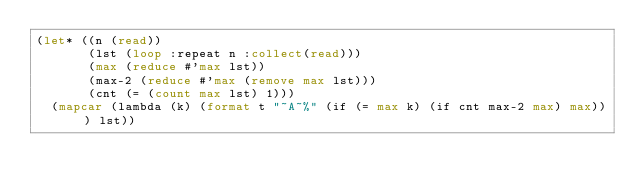Convert code to text. <code><loc_0><loc_0><loc_500><loc_500><_Lisp_>(let* ((n (read))
       (lst (loop :repeat n :collect(read)))
       (max (reduce #'max lst))
       (max-2 (reduce #'max (remove max lst)))
       (cnt (= (count max lst) 1)))
  (mapcar (lambda (k) (format t "~A~%" (if (= max k) (if cnt max-2 max) max))) lst))</code> 